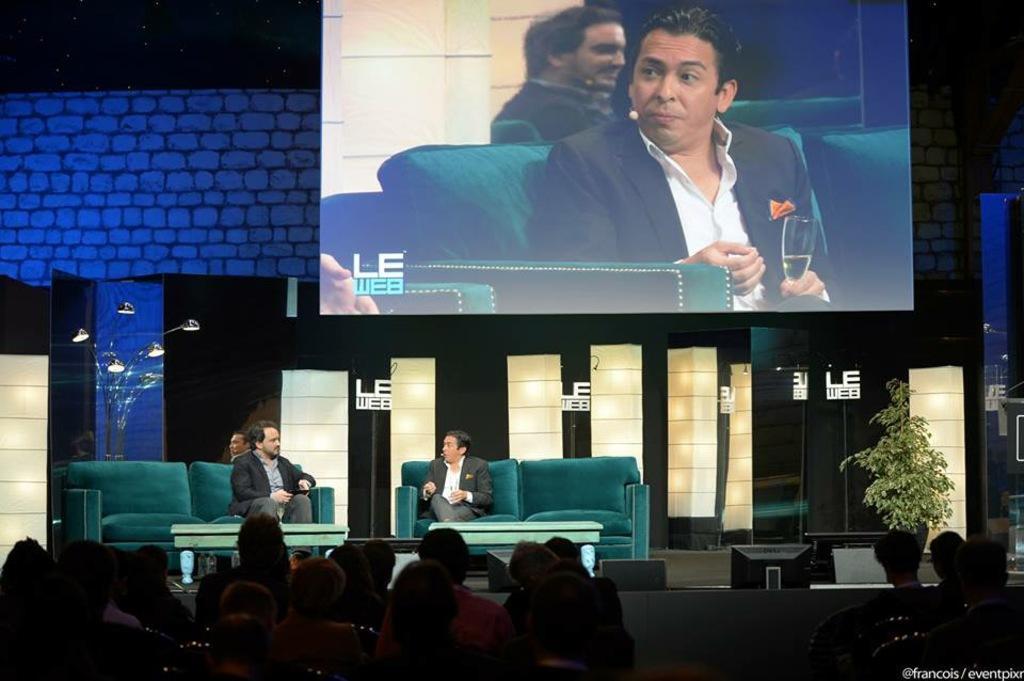Could you give a brief overview of what you see in this image? In the foreground of this image, on the bottom, there are persons sitting on the chairs. In the background, there are two men sitting on the couches and in front of them, there are tables. On the left, there are few lights. On the right, there is a plant. On the top, there is the screen. 